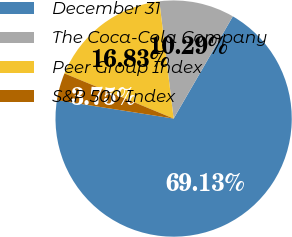<chart> <loc_0><loc_0><loc_500><loc_500><pie_chart><fcel>December 31<fcel>The Coca-Cola Company<fcel>Peer Group Index<fcel>S&P 500 Index<nl><fcel>69.14%<fcel>10.29%<fcel>16.83%<fcel>3.75%<nl></chart> 